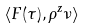Convert formula to latex. <formula><loc_0><loc_0><loc_500><loc_500>\langle F ( \tau ) , \rho ^ { z } \nu \rangle</formula> 